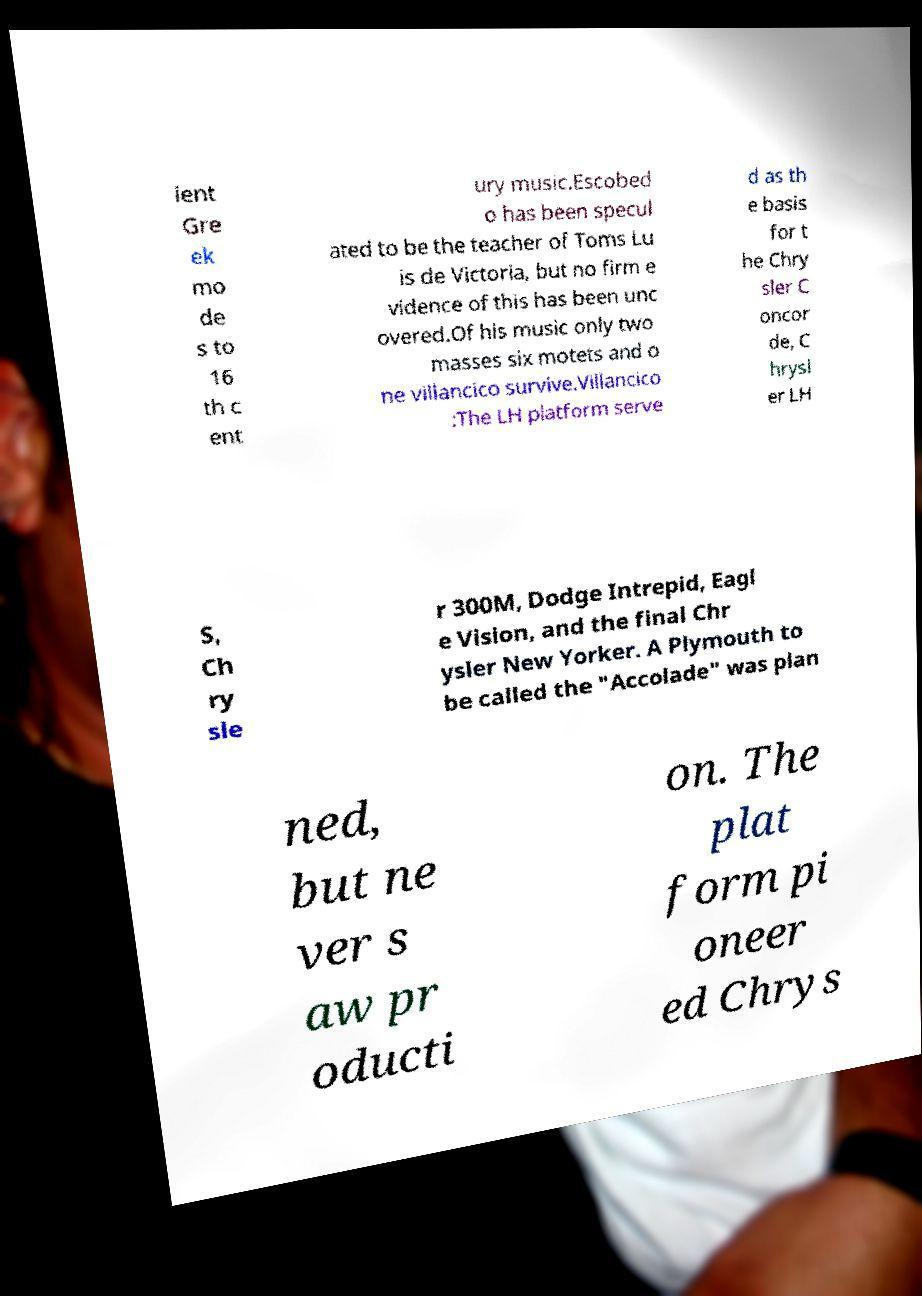What messages or text are displayed in this image? I need them in a readable, typed format. ient Gre ek mo de s to 16 th c ent ury music.Escobed o has been specul ated to be the teacher of Toms Lu is de Victoria, but no firm e vidence of this has been unc overed.Of his music only two masses six motets and o ne villancico survive.Villancico :The LH platform serve d as th e basis for t he Chry sler C oncor de, C hrysl er LH S, Ch ry sle r 300M, Dodge Intrepid, Eagl e Vision, and the final Chr ysler New Yorker. A Plymouth to be called the "Accolade" was plan ned, but ne ver s aw pr oducti on. The plat form pi oneer ed Chrys 